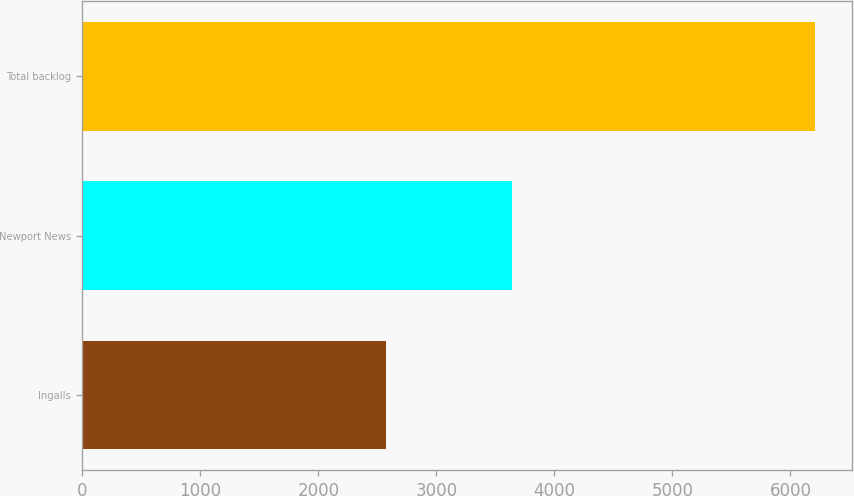Convert chart to OTSL. <chart><loc_0><loc_0><loc_500><loc_500><bar_chart><fcel>Ingalls<fcel>Newport News<fcel>Total backlog<nl><fcel>2570<fcel>3638<fcel>6208<nl></chart> 